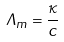<formula> <loc_0><loc_0><loc_500><loc_500>\Lambda _ { m } = \frac { \kappa } { c }</formula> 